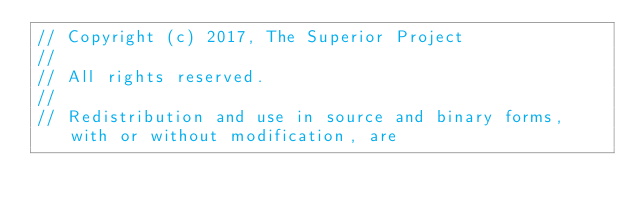Convert code to text. <code><loc_0><loc_0><loc_500><loc_500><_C++_>// Copyright (c) 2017, The Superior Project
// 
// All rights reserved.
// 
// Redistribution and use in source and binary forms, with or without modification, are</code> 